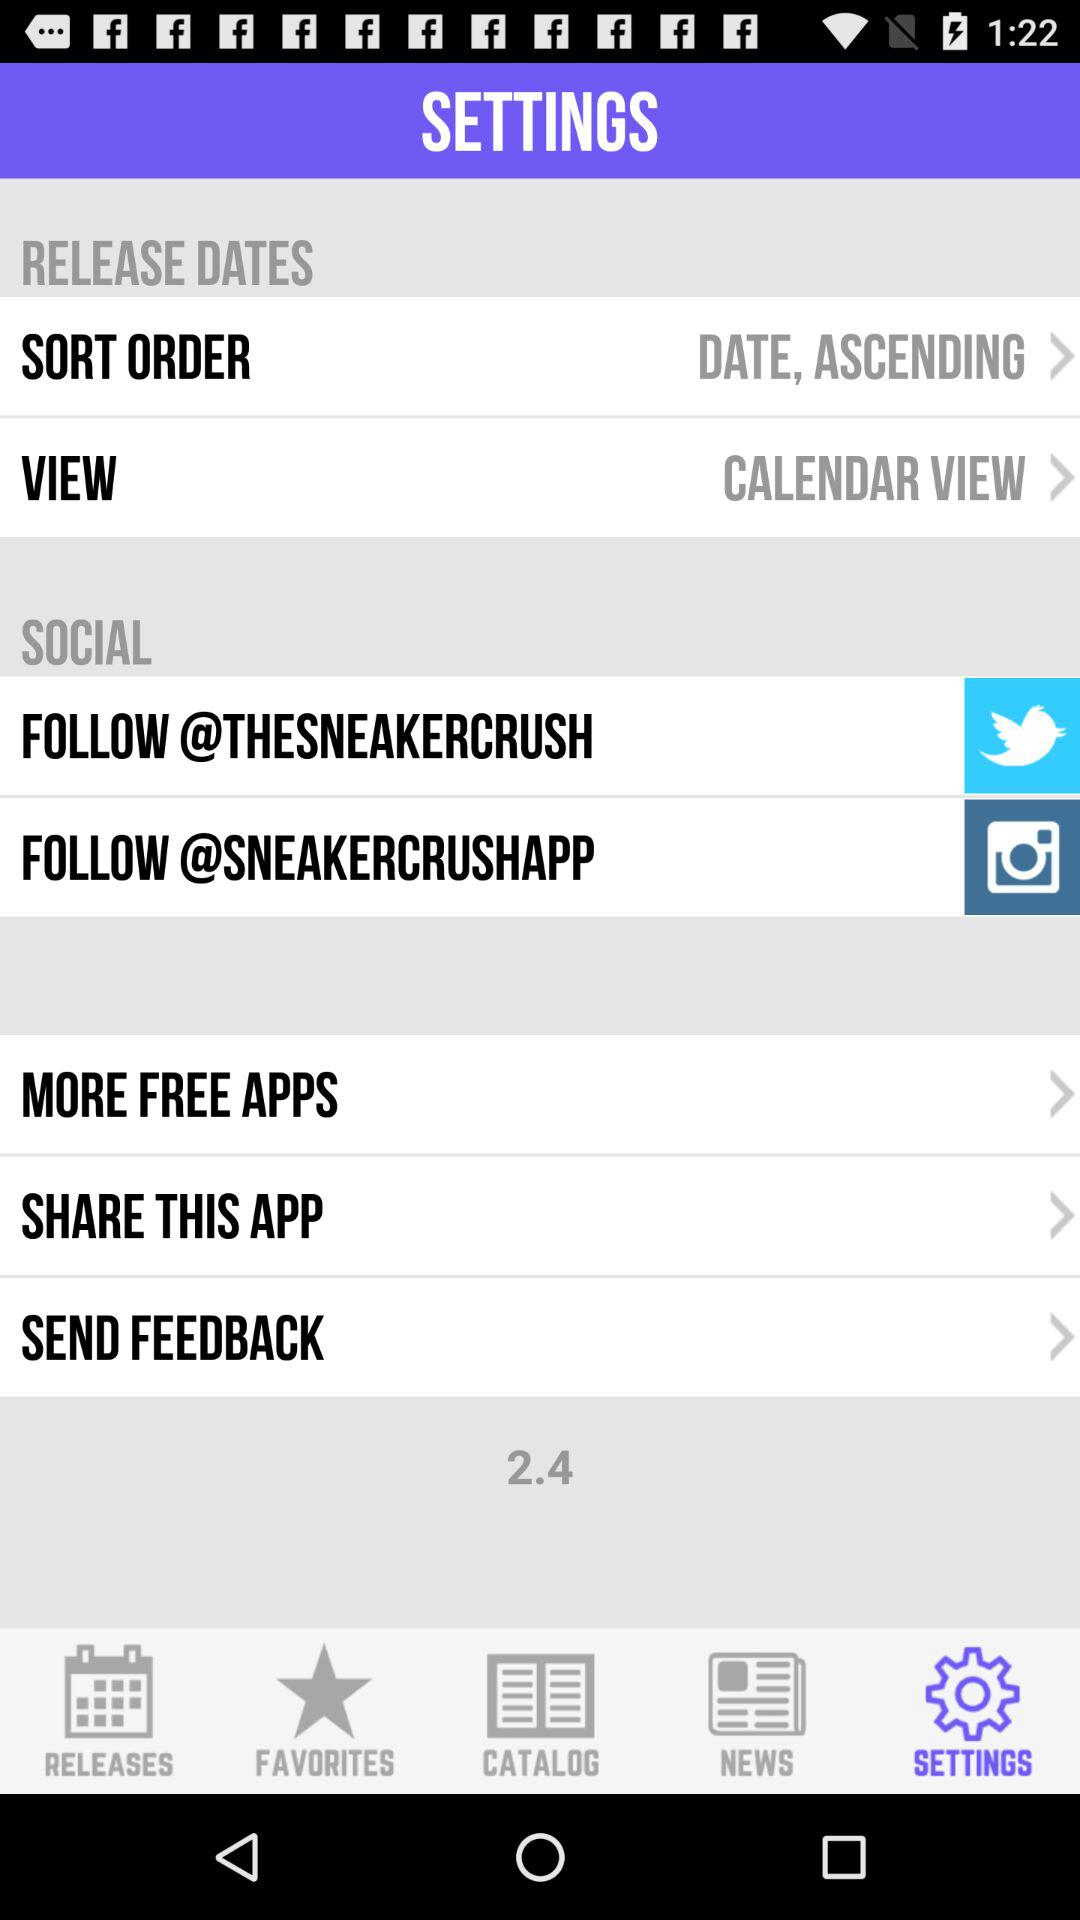Which tab is currently selected? The currently selected tab is "SETTINGS". 